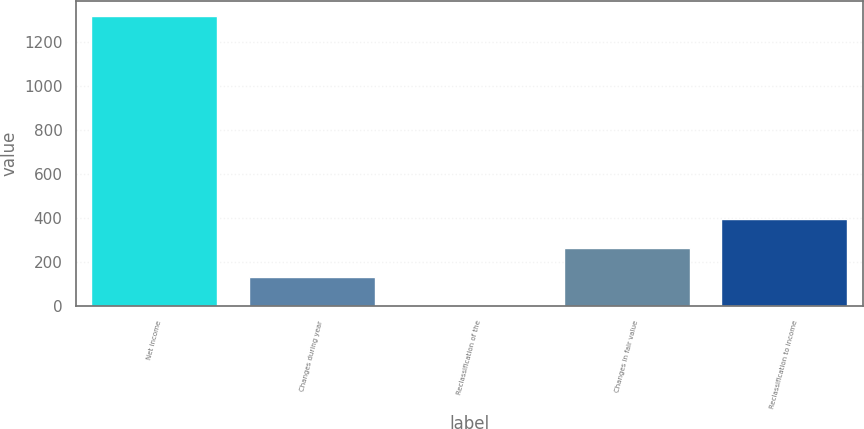<chart> <loc_0><loc_0><loc_500><loc_500><bar_chart><fcel>Net income<fcel>Changes during year<fcel>Reclassification of the<fcel>Changes in fair value<fcel>Reclassification to income<nl><fcel>1321<fcel>134.8<fcel>3<fcel>266.6<fcel>398.4<nl></chart> 